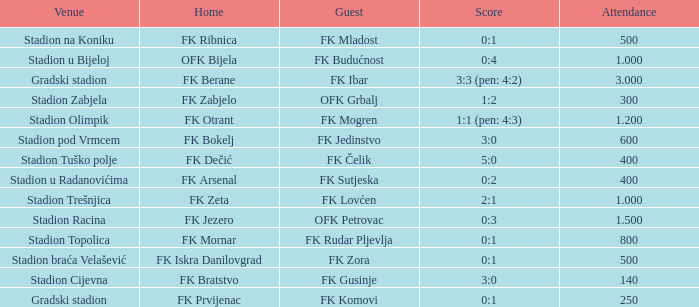What was the spectator turnout for the contest that had an away team of fk mogren? 1.2. 